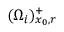<formula> <loc_0><loc_0><loc_500><loc_500>( \Omega _ { i } ) _ { x _ { 0 } , r } ^ { + }</formula> 